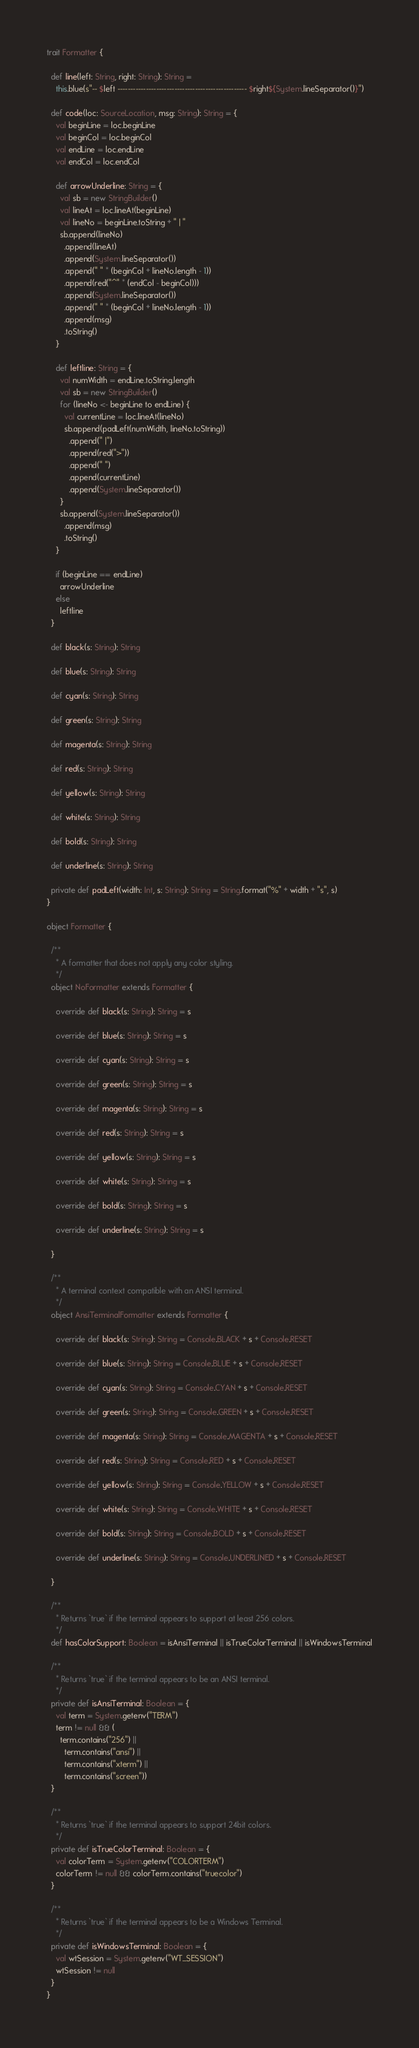<code> <loc_0><loc_0><loc_500><loc_500><_Scala_>trait Formatter {

  def line(left: String, right: String): String =
    this.blue(s"-- $left -------------------------------------------------- $right${System.lineSeparator()}")

  def code(loc: SourceLocation, msg: String): String = {
    val beginLine = loc.beginLine
    val beginCol = loc.beginCol
    val endLine = loc.endLine
    val endCol = loc.endCol

    def arrowUnderline: String = {
      val sb = new StringBuilder()
      val lineAt = loc.lineAt(beginLine)
      val lineNo = beginLine.toString + " | "
      sb.append(lineNo)
        .append(lineAt)
        .append(System.lineSeparator())
        .append(" " * (beginCol + lineNo.length - 1))
        .append(red("^" * (endCol - beginCol)))
        .append(System.lineSeparator())
        .append(" " * (beginCol + lineNo.length - 1))
        .append(msg)
        .toString()
    }

    def leftline: String = {
      val numWidth = endLine.toString.length
      val sb = new StringBuilder()
      for (lineNo <- beginLine to endLine) {
        val currentLine = loc.lineAt(lineNo)
        sb.append(padLeft(numWidth, lineNo.toString))
          .append(" |")
          .append(red(">"))
          .append(" ")
          .append(currentLine)
          .append(System.lineSeparator())
      }
      sb.append(System.lineSeparator())
        .append(msg)
        .toString()
    }

    if (beginLine == endLine)
      arrowUnderline
    else
      leftline
  }

  def black(s: String): String

  def blue(s: String): String

  def cyan(s: String): String

  def green(s: String): String

  def magenta(s: String): String

  def red(s: String): String

  def yellow(s: String): String

  def white(s: String): String

  def bold(s: String): String

  def underline(s: String): String

  private def padLeft(width: Int, s: String): String = String.format("%" + width + "s", s)
}

object Formatter {

  /**
    * A formatter that does not apply any color styling.
    */
  object NoFormatter extends Formatter {

    override def black(s: String): String = s

    override def blue(s: String): String = s

    override def cyan(s: String): String = s

    override def green(s: String): String = s

    override def magenta(s: String): String = s

    override def red(s: String): String = s

    override def yellow(s: String): String = s

    override def white(s: String): String = s

    override def bold(s: String): String = s

    override def underline(s: String): String = s

  }

  /**
    * A terminal context compatible with an ANSI terminal.
    */
  object AnsiTerminalFormatter extends Formatter {

    override def black(s: String): String = Console.BLACK + s + Console.RESET

    override def blue(s: String): String = Console.BLUE + s + Console.RESET

    override def cyan(s: String): String = Console.CYAN + s + Console.RESET

    override def green(s: String): String = Console.GREEN + s + Console.RESET

    override def magenta(s: String): String = Console.MAGENTA + s + Console.RESET

    override def red(s: String): String = Console.RED + s + Console.RESET

    override def yellow(s: String): String = Console.YELLOW + s + Console.RESET

    override def white(s: String): String = Console.WHITE + s + Console.RESET

    override def bold(s: String): String = Console.BOLD + s + Console.RESET

    override def underline(s: String): String = Console.UNDERLINED + s + Console.RESET

  }

  /**
    * Returns `true` if the terminal appears to support at least 256 colors.
    */
  def hasColorSupport: Boolean = isAnsiTerminal || isTrueColorTerminal || isWindowsTerminal

  /**
    * Returns `true` if the terminal appears to be an ANSI terminal.
    */
  private def isAnsiTerminal: Boolean = {
    val term = System.getenv("TERM")
    term != null && (
      term.contains("256") ||
        term.contains("ansi") ||
        term.contains("xterm") ||
        term.contains("screen"))
  }

  /**
    * Returns `true` if the terminal appears to support 24bit colors.
    */
  private def isTrueColorTerminal: Boolean = {
    val colorTerm = System.getenv("COLORTERM")
    colorTerm != null && colorTerm.contains("truecolor")
  }

  /**
    * Returns `true` if the terminal appears to be a Windows Terminal.
    */
  private def isWindowsTerminal: Boolean = {
    val wtSession = System.getenv("WT_SESSION")
    wtSession != null
  }
}
</code> 